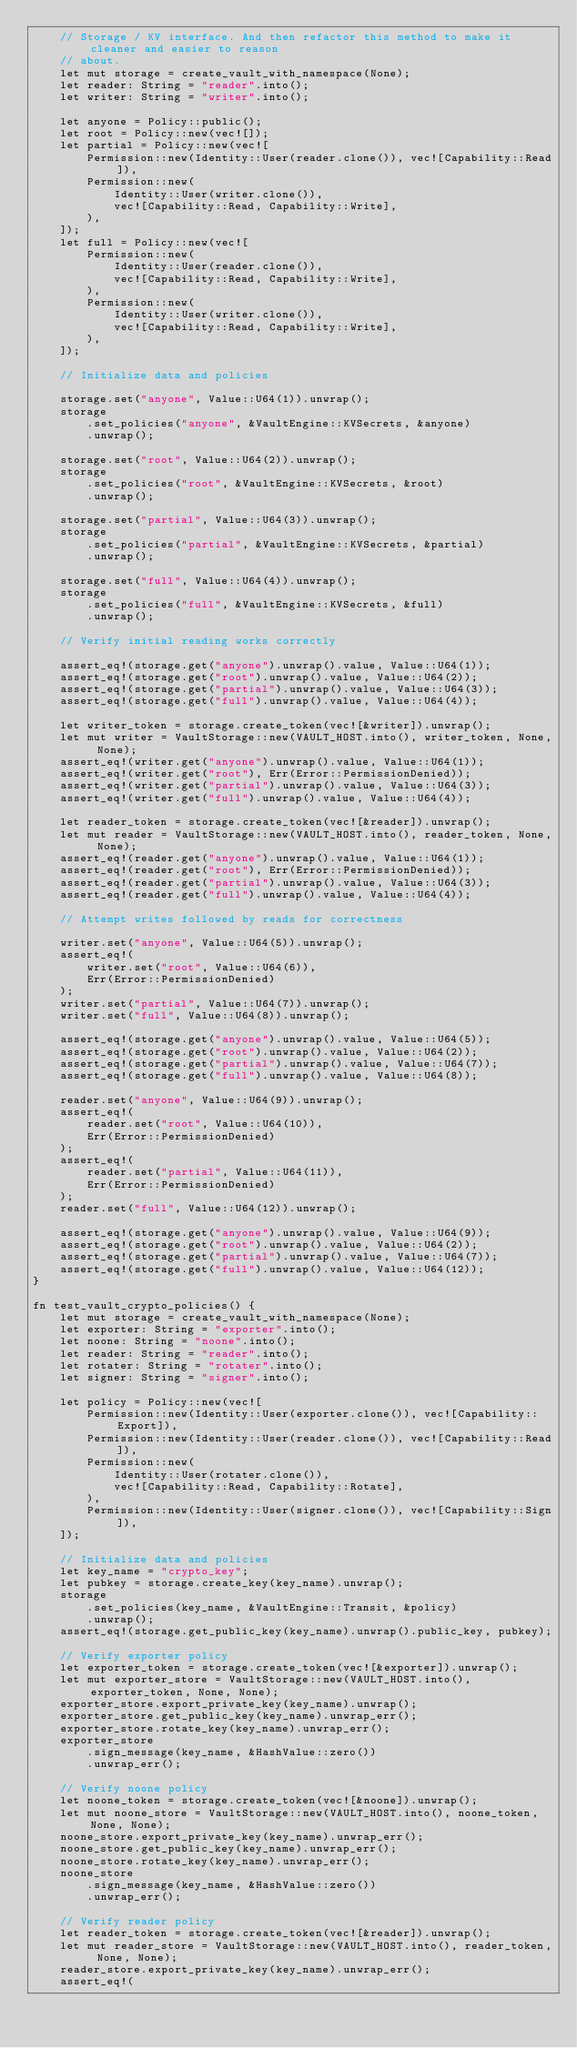<code> <loc_0><loc_0><loc_500><loc_500><_Rust_>    // Storage / KV interface. And then refactor this method to make it cleaner and easier to reason
    // about.
    let mut storage = create_vault_with_namespace(None);
    let reader: String = "reader".into();
    let writer: String = "writer".into();

    let anyone = Policy::public();
    let root = Policy::new(vec![]);
    let partial = Policy::new(vec![
        Permission::new(Identity::User(reader.clone()), vec![Capability::Read]),
        Permission::new(
            Identity::User(writer.clone()),
            vec![Capability::Read, Capability::Write],
        ),
    ]);
    let full = Policy::new(vec![
        Permission::new(
            Identity::User(reader.clone()),
            vec![Capability::Read, Capability::Write],
        ),
        Permission::new(
            Identity::User(writer.clone()),
            vec![Capability::Read, Capability::Write],
        ),
    ]);

    // Initialize data and policies

    storage.set("anyone", Value::U64(1)).unwrap();
    storage
        .set_policies("anyone", &VaultEngine::KVSecrets, &anyone)
        .unwrap();

    storage.set("root", Value::U64(2)).unwrap();
    storage
        .set_policies("root", &VaultEngine::KVSecrets, &root)
        .unwrap();

    storage.set("partial", Value::U64(3)).unwrap();
    storage
        .set_policies("partial", &VaultEngine::KVSecrets, &partial)
        .unwrap();

    storage.set("full", Value::U64(4)).unwrap();
    storage
        .set_policies("full", &VaultEngine::KVSecrets, &full)
        .unwrap();

    // Verify initial reading works correctly

    assert_eq!(storage.get("anyone").unwrap().value, Value::U64(1));
    assert_eq!(storage.get("root").unwrap().value, Value::U64(2));
    assert_eq!(storage.get("partial").unwrap().value, Value::U64(3));
    assert_eq!(storage.get("full").unwrap().value, Value::U64(4));

    let writer_token = storage.create_token(vec![&writer]).unwrap();
    let mut writer = VaultStorage::new(VAULT_HOST.into(), writer_token, None, None);
    assert_eq!(writer.get("anyone").unwrap().value, Value::U64(1));
    assert_eq!(writer.get("root"), Err(Error::PermissionDenied));
    assert_eq!(writer.get("partial").unwrap().value, Value::U64(3));
    assert_eq!(writer.get("full").unwrap().value, Value::U64(4));

    let reader_token = storage.create_token(vec![&reader]).unwrap();
    let mut reader = VaultStorage::new(VAULT_HOST.into(), reader_token, None, None);
    assert_eq!(reader.get("anyone").unwrap().value, Value::U64(1));
    assert_eq!(reader.get("root"), Err(Error::PermissionDenied));
    assert_eq!(reader.get("partial").unwrap().value, Value::U64(3));
    assert_eq!(reader.get("full").unwrap().value, Value::U64(4));

    // Attempt writes followed by reads for correctness

    writer.set("anyone", Value::U64(5)).unwrap();
    assert_eq!(
        writer.set("root", Value::U64(6)),
        Err(Error::PermissionDenied)
    );
    writer.set("partial", Value::U64(7)).unwrap();
    writer.set("full", Value::U64(8)).unwrap();

    assert_eq!(storage.get("anyone").unwrap().value, Value::U64(5));
    assert_eq!(storage.get("root").unwrap().value, Value::U64(2));
    assert_eq!(storage.get("partial").unwrap().value, Value::U64(7));
    assert_eq!(storage.get("full").unwrap().value, Value::U64(8));

    reader.set("anyone", Value::U64(9)).unwrap();
    assert_eq!(
        reader.set("root", Value::U64(10)),
        Err(Error::PermissionDenied)
    );
    assert_eq!(
        reader.set("partial", Value::U64(11)),
        Err(Error::PermissionDenied)
    );
    reader.set("full", Value::U64(12)).unwrap();

    assert_eq!(storage.get("anyone").unwrap().value, Value::U64(9));
    assert_eq!(storage.get("root").unwrap().value, Value::U64(2));
    assert_eq!(storage.get("partial").unwrap().value, Value::U64(7));
    assert_eq!(storage.get("full").unwrap().value, Value::U64(12));
}

fn test_vault_crypto_policies() {
    let mut storage = create_vault_with_namespace(None);
    let exporter: String = "exporter".into();
    let noone: String = "noone".into();
    let reader: String = "reader".into();
    let rotater: String = "rotater".into();
    let signer: String = "signer".into();

    let policy = Policy::new(vec![
        Permission::new(Identity::User(exporter.clone()), vec![Capability::Export]),
        Permission::new(Identity::User(reader.clone()), vec![Capability::Read]),
        Permission::new(
            Identity::User(rotater.clone()),
            vec![Capability::Read, Capability::Rotate],
        ),
        Permission::new(Identity::User(signer.clone()), vec![Capability::Sign]),
    ]);

    // Initialize data and policies
    let key_name = "crypto_key";
    let pubkey = storage.create_key(key_name).unwrap();
    storage
        .set_policies(key_name, &VaultEngine::Transit, &policy)
        .unwrap();
    assert_eq!(storage.get_public_key(key_name).unwrap().public_key, pubkey);

    // Verify exporter policy
    let exporter_token = storage.create_token(vec![&exporter]).unwrap();
    let mut exporter_store = VaultStorage::new(VAULT_HOST.into(), exporter_token, None, None);
    exporter_store.export_private_key(key_name).unwrap();
    exporter_store.get_public_key(key_name).unwrap_err();
    exporter_store.rotate_key(key_name).unwrap_err();
    exporter_store
        .sign_message(key_name, &HashValue::zero())
        .unwrap_err();

    // Verify noone policy
    let noone_token = storage.create_token(vec![&noone]).unwrap();
    let mut noone_store = VaultStorage::new(VAULT_HOST.into(), noone_token, None, None);
    noone_store.export_private_key(key_name).unwrap_err();
    noone_store.get_public_key(key_name).unwrap_err();
    noone_store.rotate_key(key_name).unwrap_err();
    noone_store
        .sign_message(key_name, &HashValue::zero())
        .unwrap_err();

    // Verify reader policy
    let reader_token = storage.create_token(vec![&reader]).unwrap();
    let mut reader_store = VaultStorage::new(VAULT_HOST.into(), reader_token, None, None);
    reader_store.export_private_key(key_name).unwrap_err();
    assert_eq!(</code> 